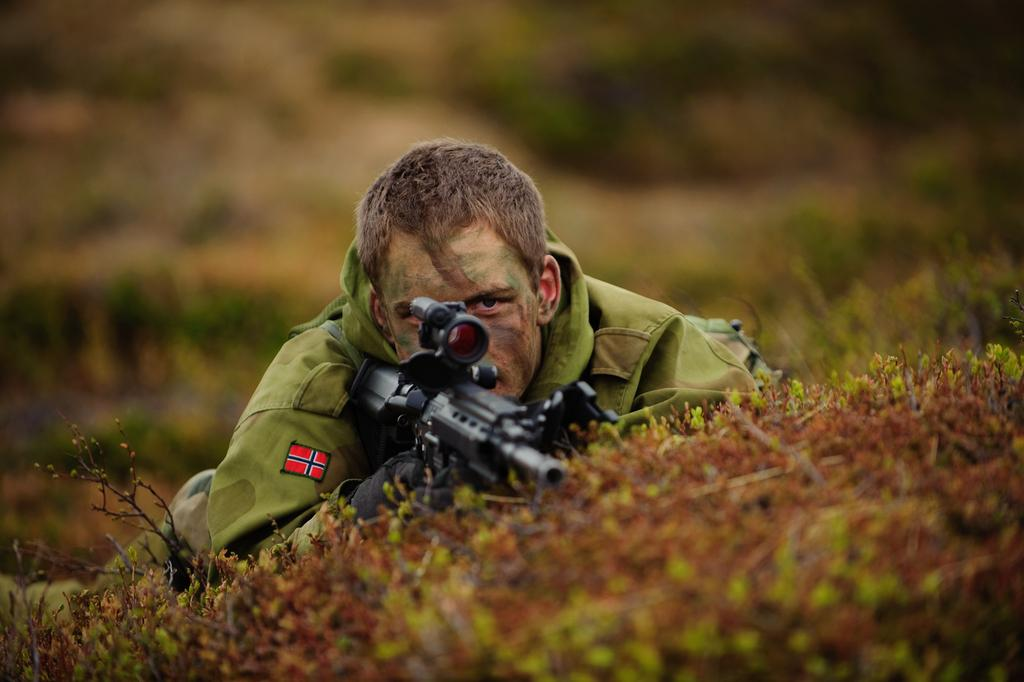Who is present in the image? There is a man in the image. What is the man wearing? The man is wearing a camouflage dress. What is the man doing in the image? The man is laying on the land. What is the man holding in the image? The man is holding a gun. What is the condition of the land in the image? The land is covered with grass. How would you describe the background of the image? The background of the image is blurry. What type of grain is being harvested in the background of the image? There is no grain visible in the image; the background is blurry. How many bushes can be seen in the foreground of the image? There are no bushes present in the image; the man is laying on the grass-covered land. 